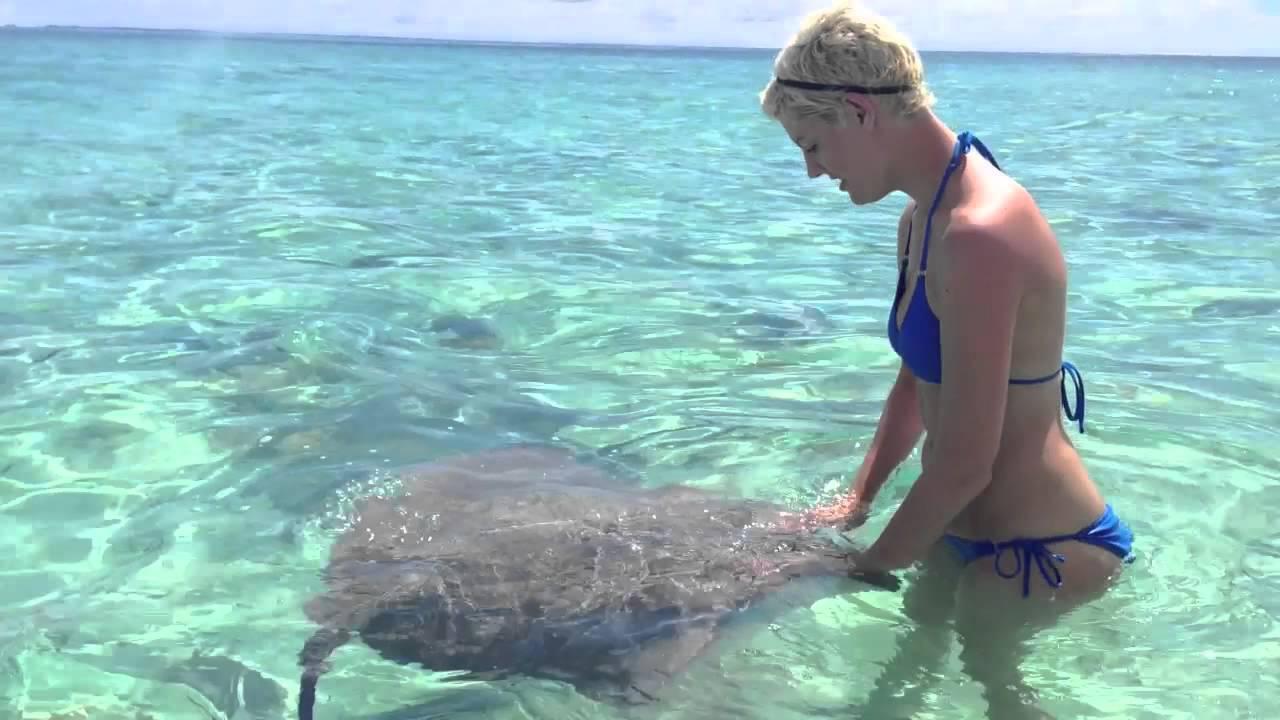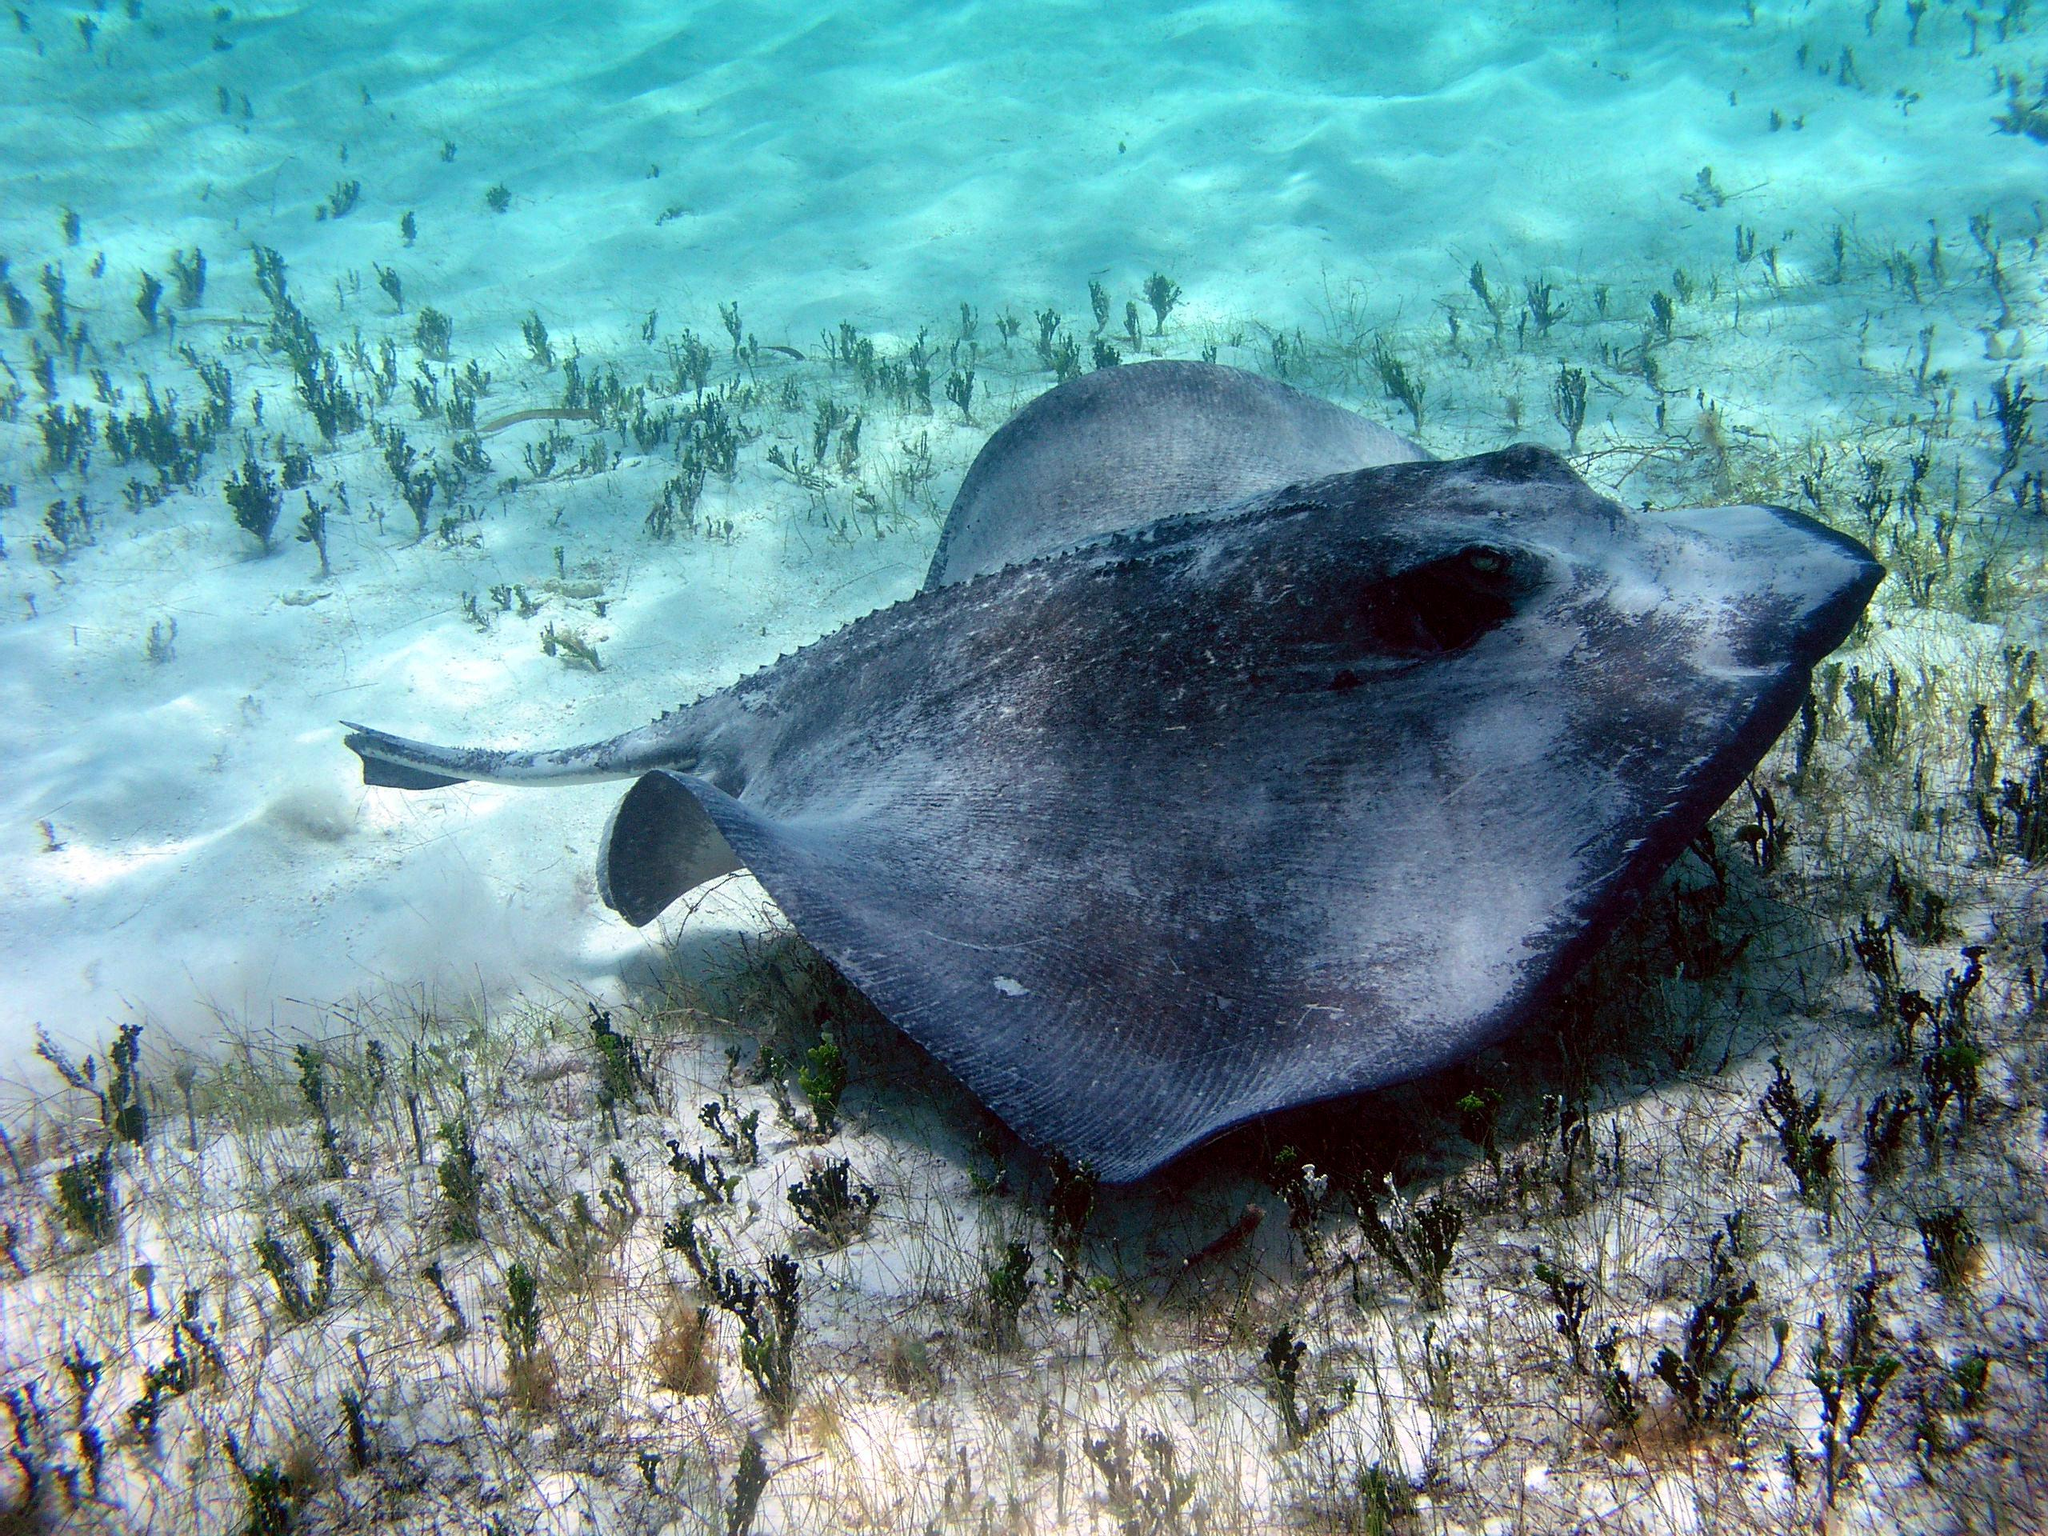The first image is the image on the left, the second image is the image on the right. Analyze the images presented: Is the assertion "The woman in the left image is wearing a bikini; we can clearly see most of her bathing suit." valid? Answer yes or no. Yes. The first image is the image on the left, the second image is the image on the right. Given the left and right images, does the statement "A woman in a bikini is in the water next to a gray stingray." hold true? Answer yes or no. Yes. 